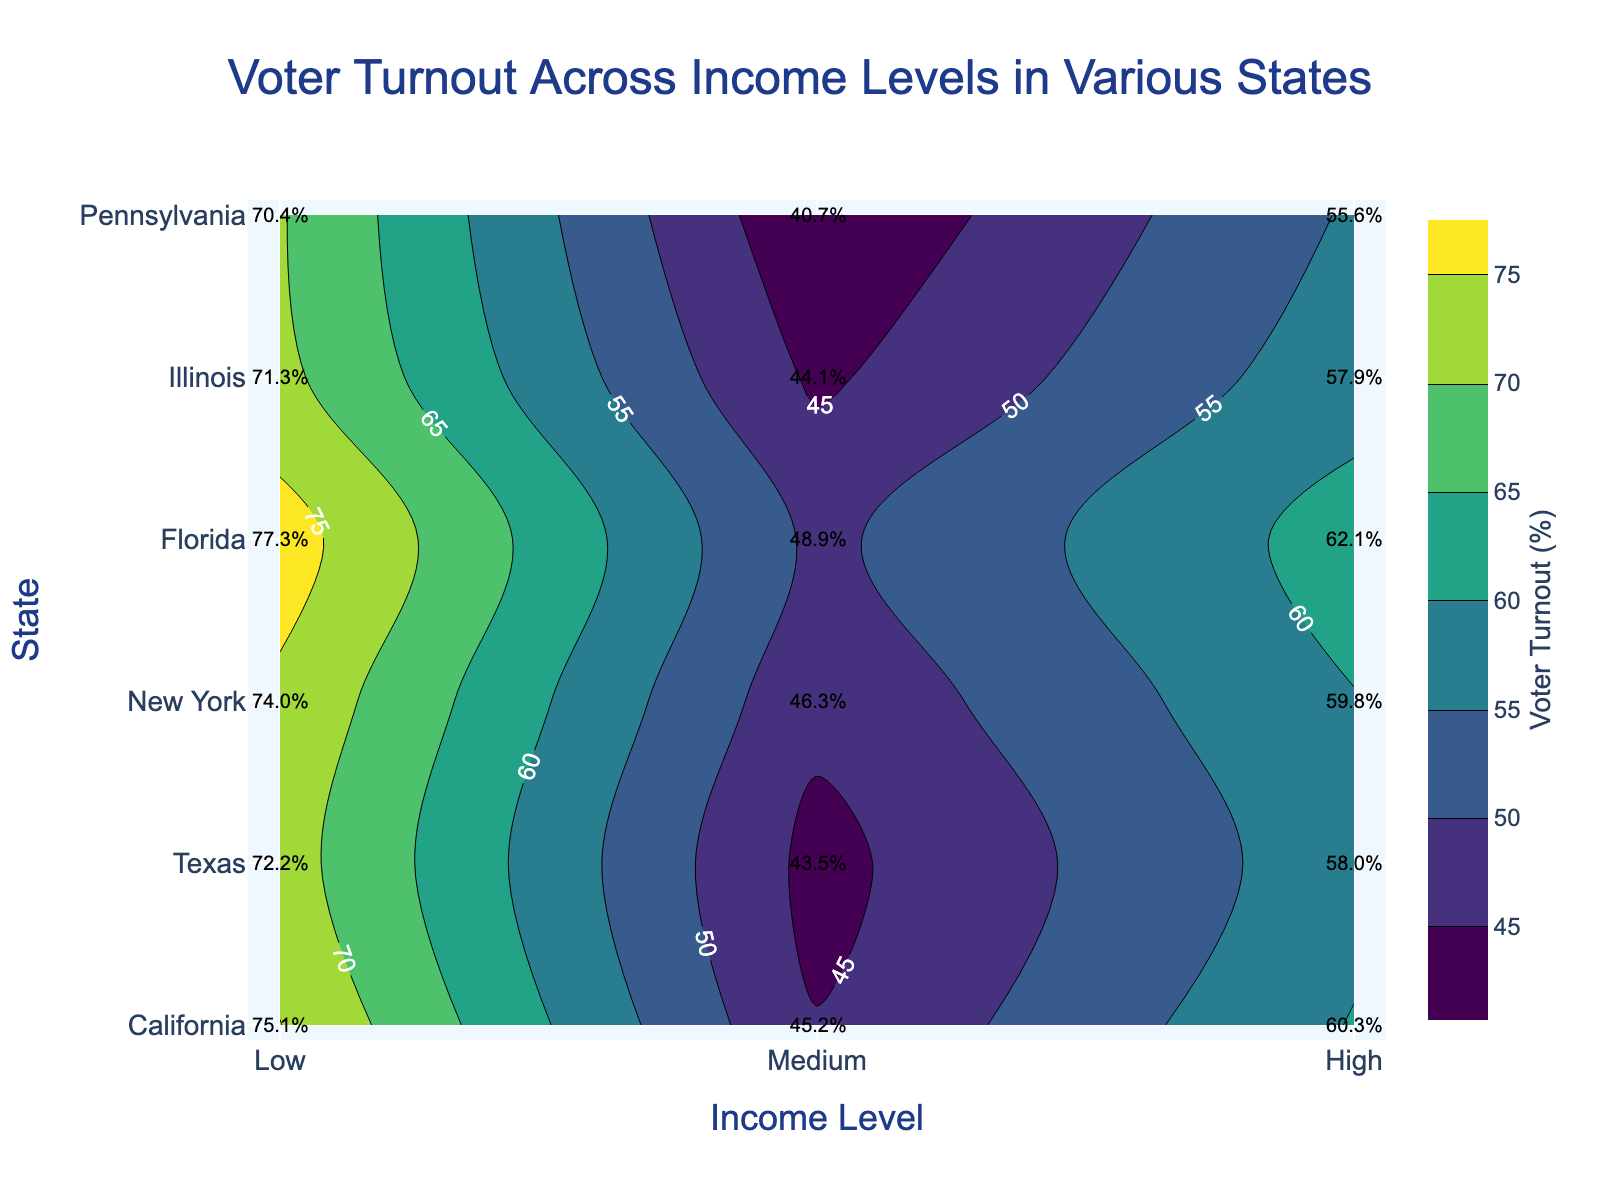What is the title of the plot? The title is prominently displayed at the top of the plot in large font size, providing a summary of the subject of the visualization.
Answer: Voter Turnout Across Income Levels in Various States What axis shows the different states? The y-axis, labeled "State" with a larger font size, displays the various states included in the data.
Answer: y-axis Which income level has the lowest voter turnout in California? Look at the labels inside the contour plot for California, which has the coordinates along the y-axis. Identify the lowest percentage for the three income level categories.
Answer: Low What is the voter turnout percentage for the medium-income level in Texas? Locate Texas on the y-axis and follow horizontally to the Medium income level category on the x-axis. Read the labeled percentage in the contour plot at this intersection.
Answer: 55.6% Which state has the highest voter turnout for the high-income level? From all the states listed along the y-axis, find the highest voter turnout percentage in the "High" income level category on the contour plot.
Answer: New York What is the difference in voter turnout between low and high-income levels in New York? Identify the voter turnout percentages for both the low and high-income categories in New York from the contour plot, then subtract the lower percentage from the higher one.
Answer: 77.3% - 48.9% = 28.4% Is voter turnout higher in Florida or Illinois for medium-income levels? Compare the voter turnout percentages for the "Medium" income level in both Florida and Illinois from the labels in the contour plot.
Answer: Illinois Which state shows the smallest range of voter turnout percentages across income levels? For each state, compute the difference between the highest and lowest voter turnout percentages across income levels, and identify the state with the smallest difference.
Answer: Pennsylvania What is the average voter turnout percentage for high-income levels across all states? Add the voter turnout percentages for high-income levels in all states shown on the contour plot and divide by the number of states.
Answer: (75.1 + 70.4 + 77.3 + 72.2 + 74.0 + 71.3) / 6 = 73.4% In which state is the voter turnout for low-income levels closest to 45%? Examine the low-income voter turnout percentages for each state and identify the one that is nearest to 45% from the contour plot labels.
Answer: California 